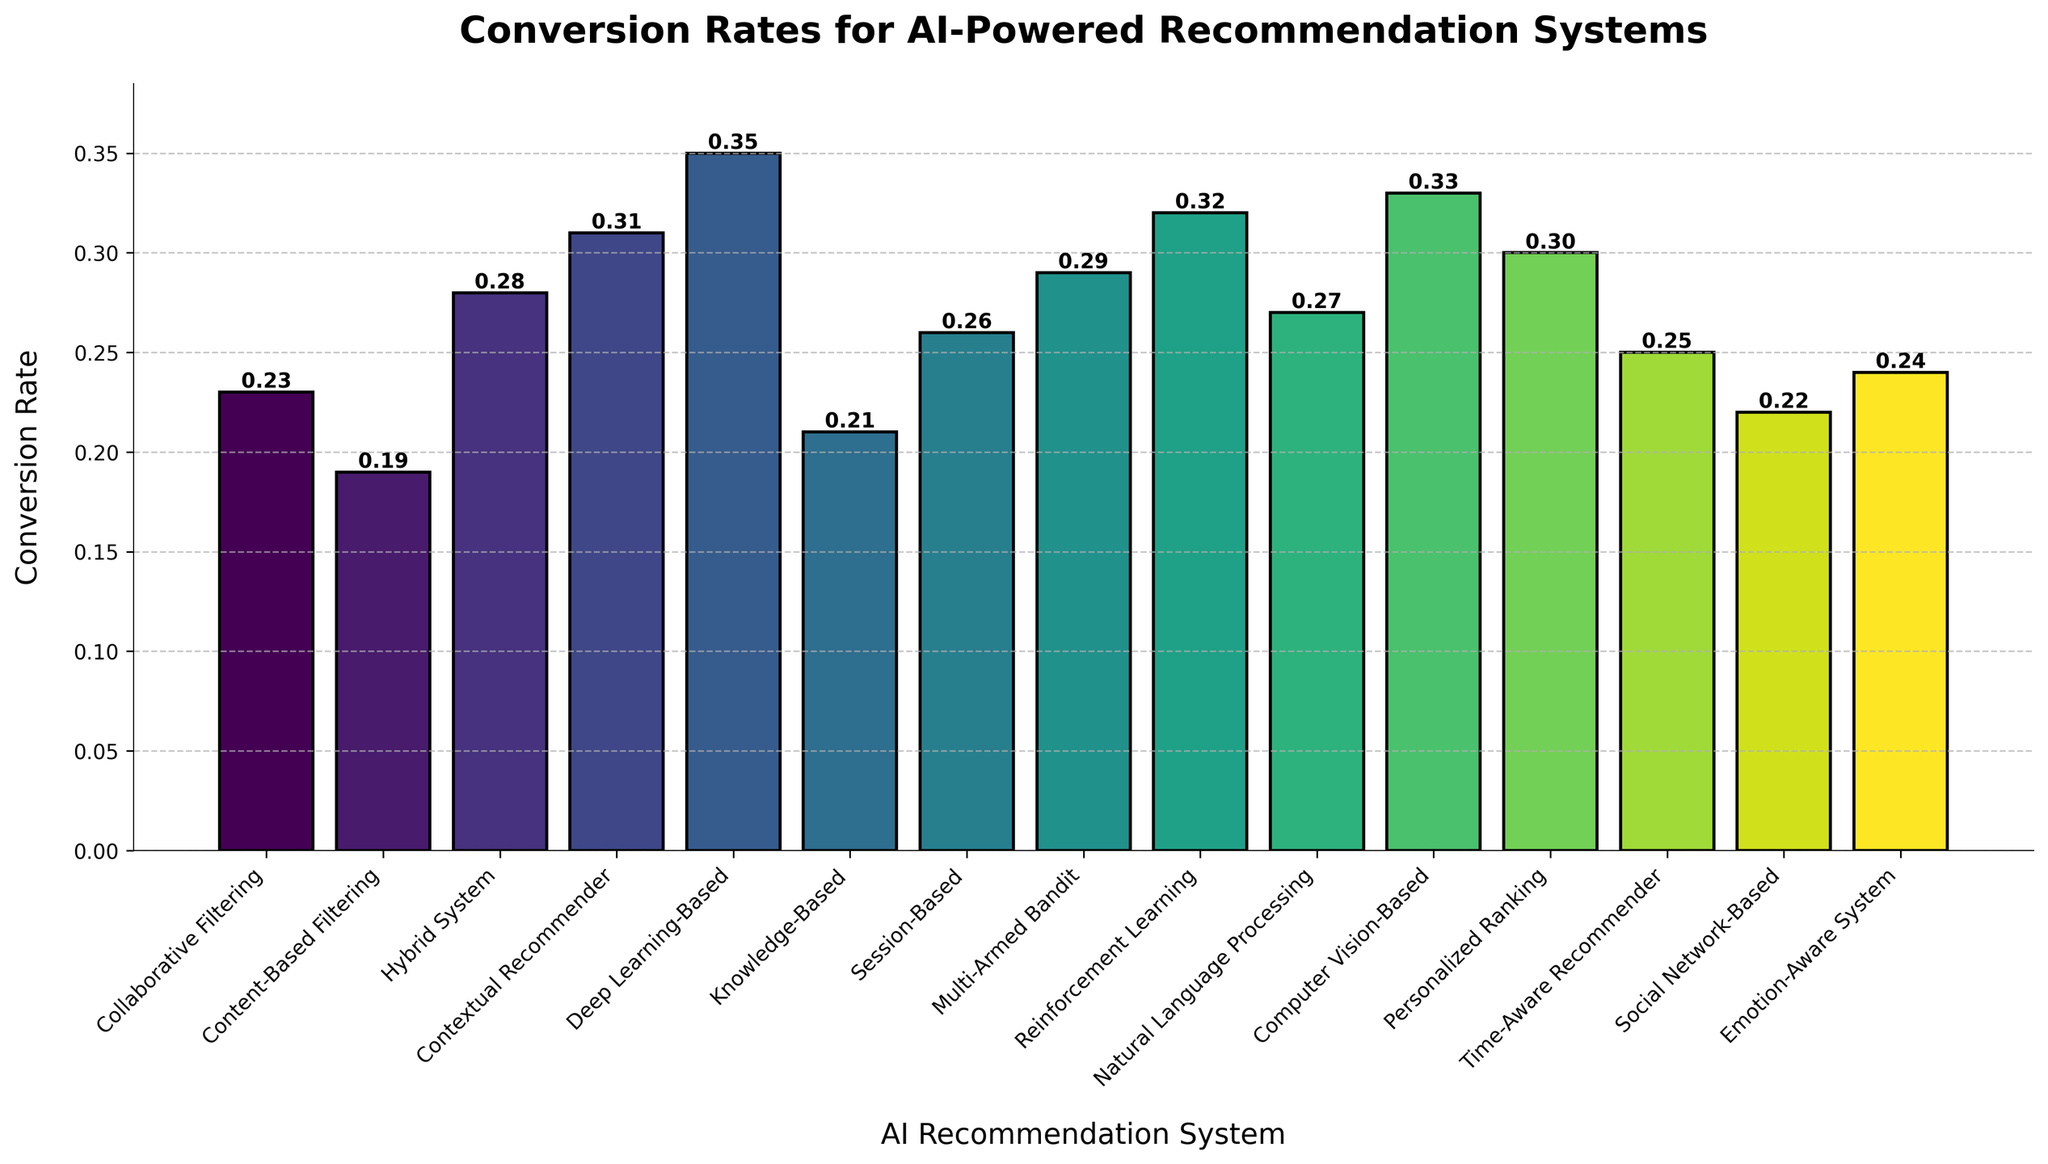Which AI-powered recommendation system has the highest conversion rate? Look for the tallest bar in the chart. The tallest bar represents the Deep Learning-Based system with a conversion rate of 0.35.
Answer: Deep Learning-Based Compare the conversion rates of the Collaborative Filtering and the Knowledge-Based systems. Which one is higher, and by how much? Observe the heights of the bars for the Collaborative Filtering and Knowledge-Based systems. Collaborative Filtering is at 0.23 and Knowledge-Based is at 0.21. Subtract 0.21 from 0.23.
Answer: Collaborative Filtering by 0.02 What is the average conversion rate of the top 3 AI-powered recommendation systems? Identify the top 3 conversion rates: Deep Learning-Based (0.35), Computer Vision-Based (0.33), and Reinforcement Learning (0.32). Calculate the average: (0.35 + 0.33 + 0.32) / 3 = 1.00 / 3.
Answer: 0.33 Which recommendation system has the lowest conversion rate and what is it? Identify the shortest bar in the chart. The shortest bar represents the Content-Based Filtering system with a conversion rate of 0.19.
Answer: Content-Based Filtering, 0.19 What is the total conversion rate of the Hybrid System, Contextual Recommender, and Multi-Armed Bandit systems combined? Add the conversion rates for these systems: Hybrid System (0.28), Contextual Recommender (0.31), and Multi-Armed Bandit (0.29). The total is 0.28 + 0.31 + 0.29 = 0.88.
Answer: 0.88 How many AI recommendation systems have a conversion rate of 0.30 or higher? Count the bars with heights 0.30 or above. These are: Contextual Recommender (0.31), Deep Learning-Based (0.35), Reinforcement Learning (0.32), Computer Vision-Based (0.33), and Personalized Ranking (0.30). Total count is 5.
Answer: 5 What is the combined difference between the conversion rates of the Personalized Ranking and Session-Based systems compared to the Natural Language Processing system? Find the differences: Personalized Ranking (0.30) - Natural Language Processing (0.27) = 0.03 and Session-Based (0.26) - Natural Language Processing (0.27) = -0.01. Sum the absolute values: 0.03 + 0.01 = 0.04.
Answer: 0.04 Which system has a higher conversion rate: Social Network-Based or Emotion-Aware System, and by how much? Look at the bars for Social Network-Based (0.22) and Emotion-Aware System (0.24). Subtract 0.22 from 0.24 to find the difference.
Answer: Emotion-Aware System by 0.02 Rank the Deep Learning-Based, Computer Vision-Based, and Natural Language Processing systems from highest to lowest conversion rate. Compare the heights of the bars: Deep Learning-Based (0.35), Computer Vision-Based (0.33), and Natural Language Processing (0.27). Order them as Deep Learning-Based, Computer Vision-Based, and Natural Language Processing.
Answer: Deep Learning-Based, Computer Vision-Based, Natural Language Processing 